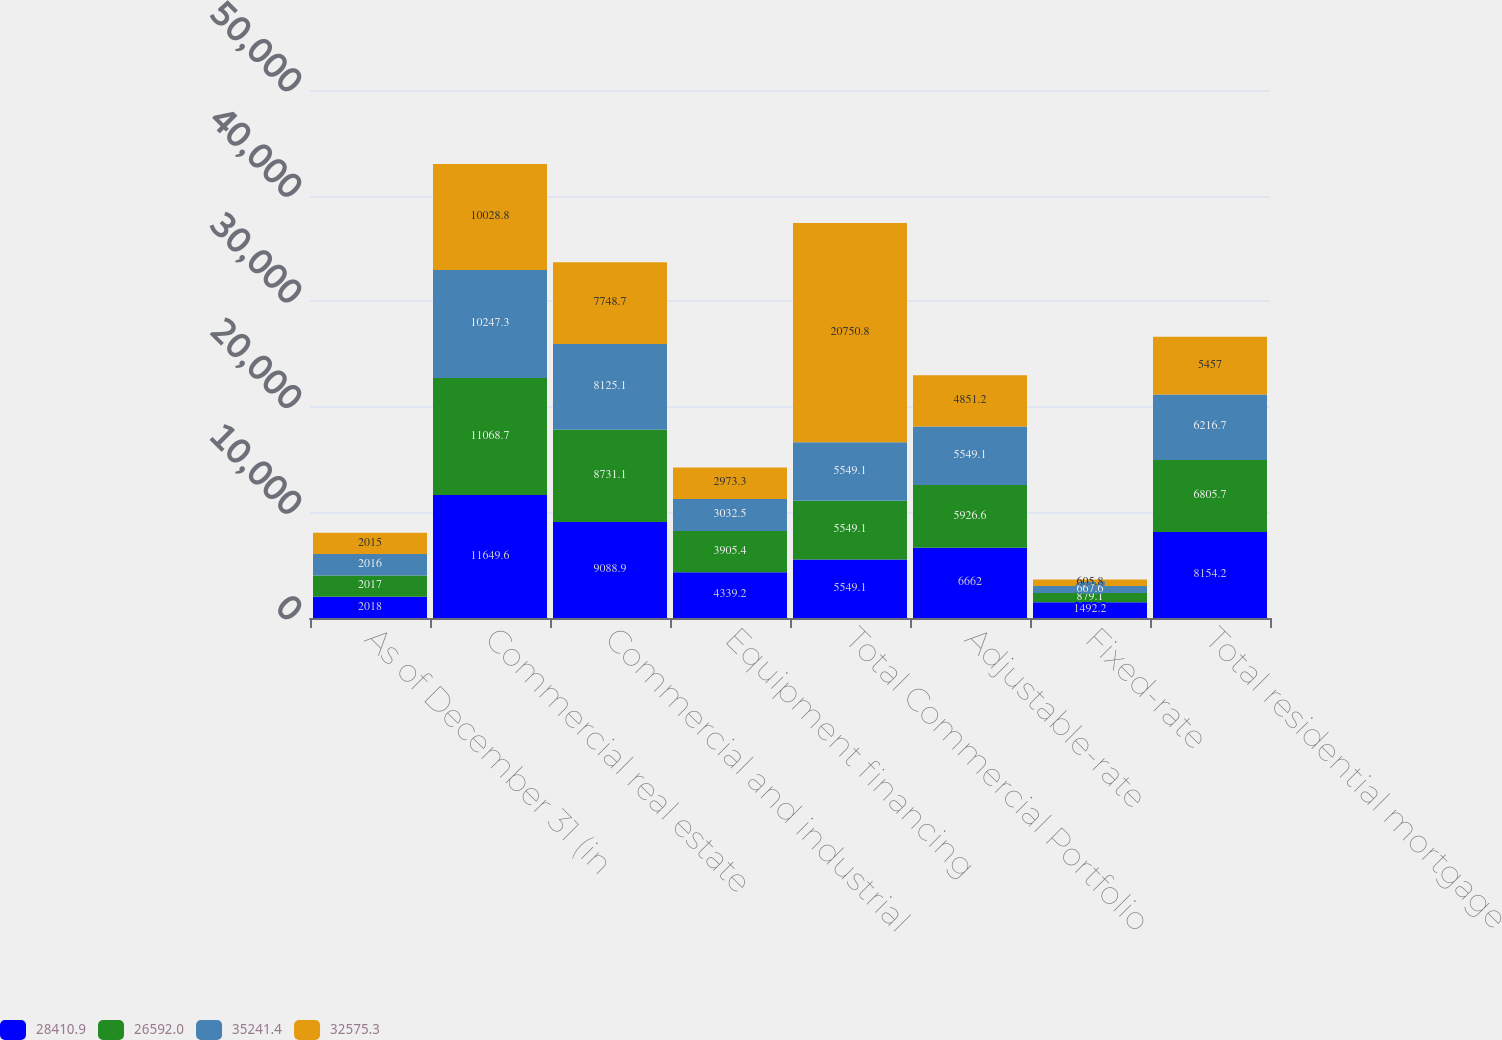Convert chart. <chart><loc_0><loc_0><loc_500><loc_500><stacked_bar_chart><ecel><fcel>As of December 31 (in<fcel>Commercial real estate<fcel>Commercial and industrial<fcel>Equipment financing<fcel>Total Commercial Portfolio<fcel>Adjustable-rate<fcel>Fixed-rate<fcel>Total residential mortgage<nl><fcel>28410.9<fcel>2018<fcel>11649.6<fcel>9088.9<fcel>4339.2<fcel>5549.1<fcel>6662<fcel>1492.2<fcel>8154.2<nl><fcel>26592<fcel>2017<fcel>11068.7<fcel>8731.1<fcel>3905.4<fcel>5549.1<fcel>5926.6<fcel>879.1<fcel>6805.7<nl><fcel>35241.4<fcel>2016<fcel>10247.3<fcel>8125.1<fcel>3032.5<fcel>5549.1<fcel>5549.1<fcel>667.6<fcel>6216.7<nl><fcel>32575.3<fcel>2015<fcel>10028.8<fcel>7748.7<fcel>2973.3<fcel>20750.8<fcel>4851.2<fcel>605.8<fcel>5457<nl></chart> 